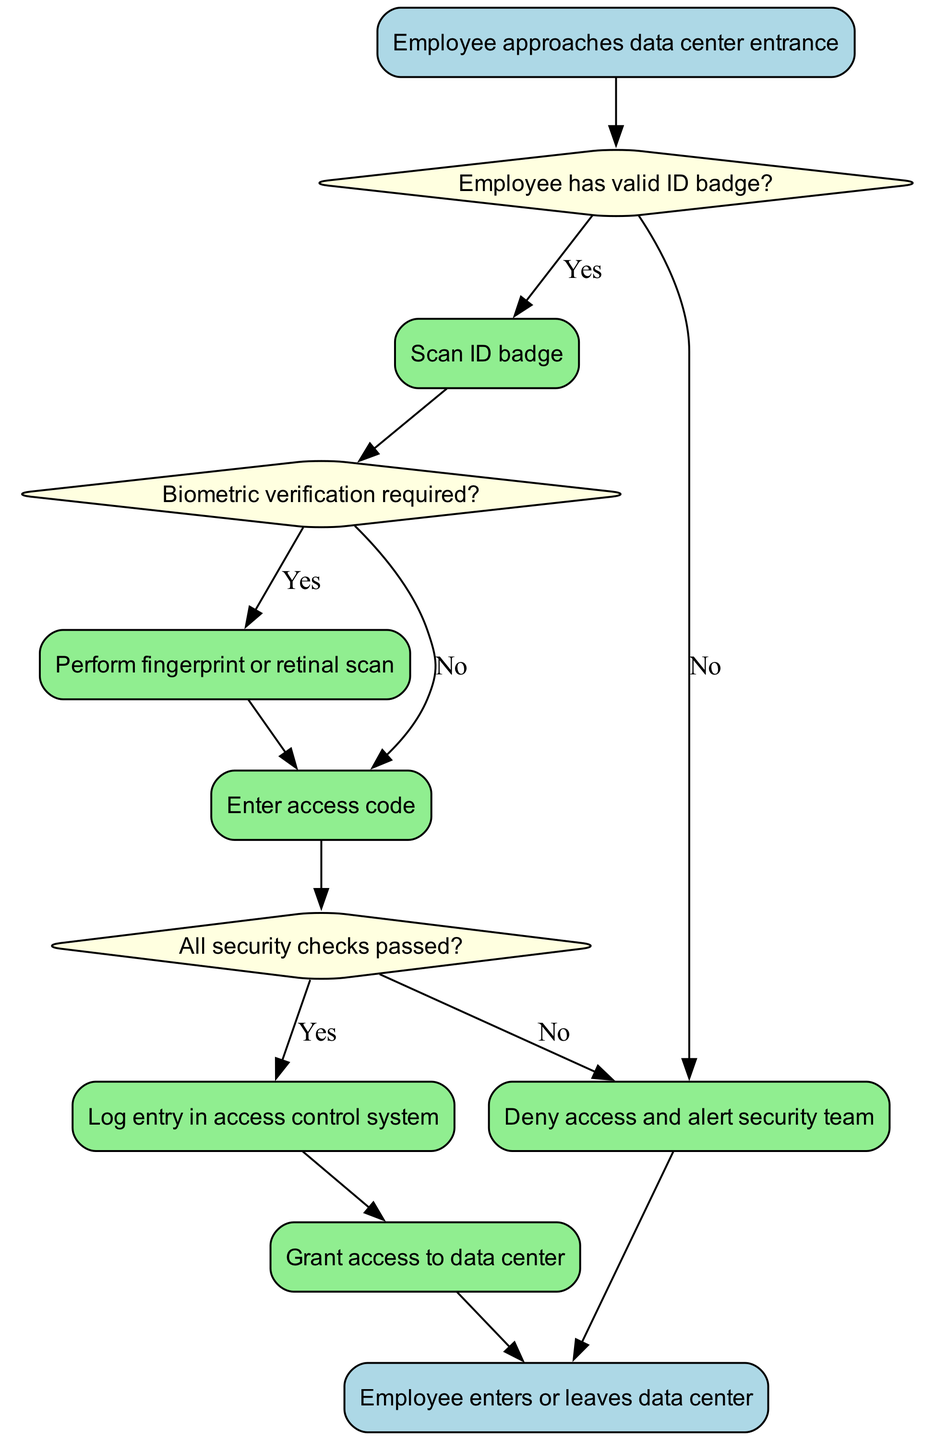What is the first action in the procedure? The first action in the procedure is indicated after the start node, which states that an employee approaches the data center entrance.
Answer: Employee approaches data center entrance How many decision nodes are present in the diagram? The total number of decision nodes can be counted by identifying the diamond-shaped nodes in the diagram, which includes three: one for valid ID badge, one for biometric verification, and one for security checks.
Answer: Three What happens if the employee does not have a valid ID badge? If the employee does not have a valid ID badge, the flow indicates the action to deny access and alert the security team, clearly marked with an edge from the decision node.
Answer: Deny access and alert security team What is required if biometric verification is needed? If biometric verification is required, the next action specified in the diagram is to perform a fingerprint or retinal scan, leading directly from the corresponding decision node.
Answer: Perform fingerprint or retinal scan What is the final node in the flow chart? The final node, where the flow terminates, shows the outcome of the entry, representing both possible situations: whether the employee enters or leaves the data center.
Answer: Employee enters or leaves data center What action is taken if all security checks are passed? When all security checks are passed, the next specified action is to log entry in the access control system before granting access, which follows directly from the decision node confirming all checks.
Answer: Log entry in access control system What leads to granting access to the data center? Granting access to the data center is reached after logging the entry in the access control system, clearly presented as an action following a check of the security criteria being met.
Answer: Grant access to data center What happens after scanning the ID badge? After scanning the ID badge, the relevant transition is to check whether biometric verification is required, making this the next step in the flow.
Answer: Check biometric verification requirement 